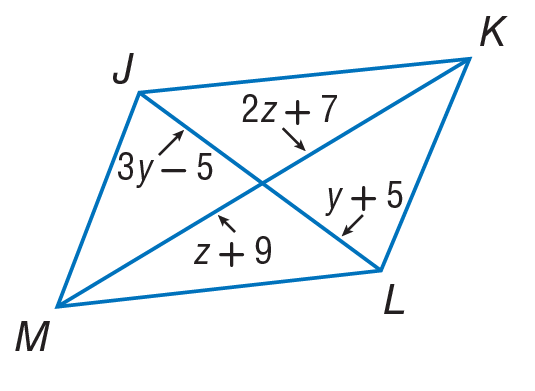Question: Use parallelogram to find z.
Choices:
A. 2
B. 7
C. 11
D. 13
Answer with the letter. Answer: A Question: Use parallelogram to find y.
Choices:
A. 5
B. 10
C. 15
D. 20
Answer with the letter. Answer: A 